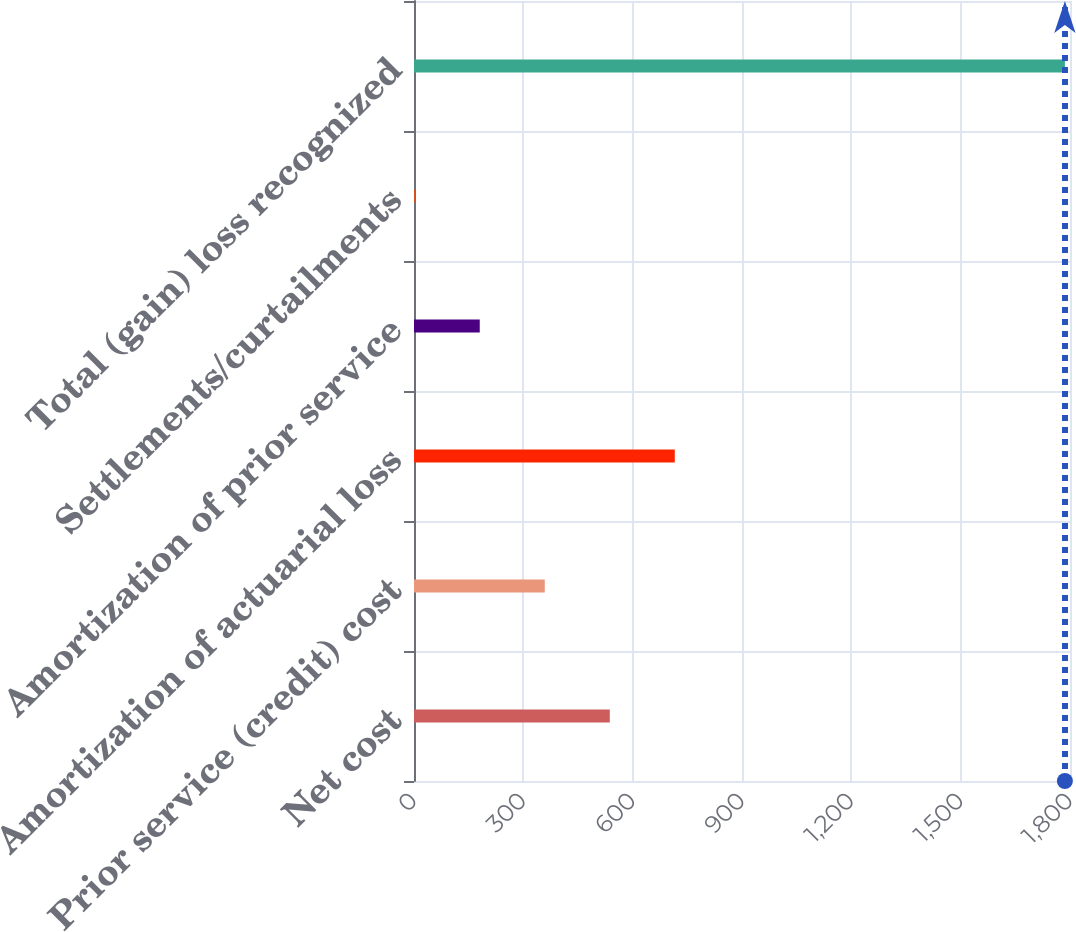Convert chart to OTSL. <chart><loc_0><loc_0><loc_500><loc_500><bar_chart><fcel>Net cost<fcel>Prior service (credit) cost<fcel>Amortization of actuarial loss<fcel>Amortization of prior service<fcel>Settlements/curtailments<fcel>Total (gain) loss recognized<nl><fcel>537.2<fcel>358.8<fcel>715.6<fcel>180.4<fcel>2<fcel>1786<nl></chart> 